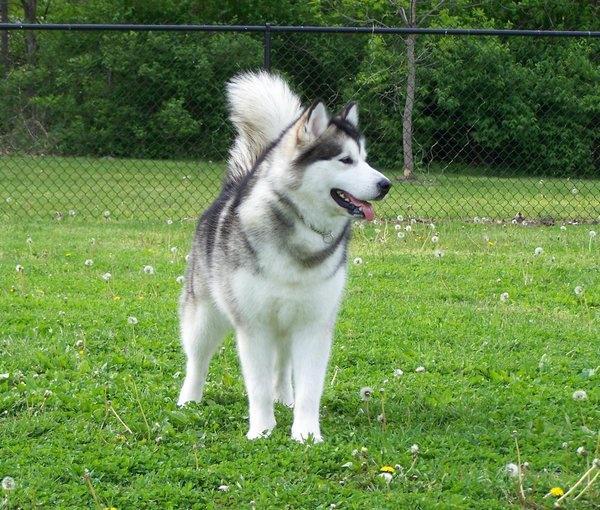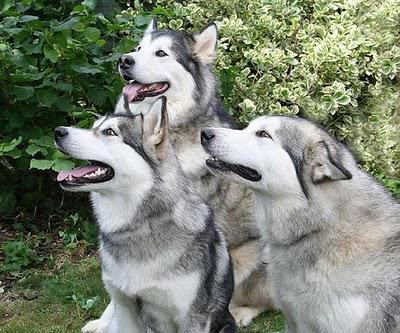The first image is the image on the left, the second image is the image on the right. Assess this claim about the two images: "The left and right image contains the same number of dogs.". Correct or not? Answer yes or no. No. The first image is the image on the left, the second image is the image on the right. Analyze the images presented: Is the assertion "A dog is standing next to a person." valid? Answer yes or no. No. 